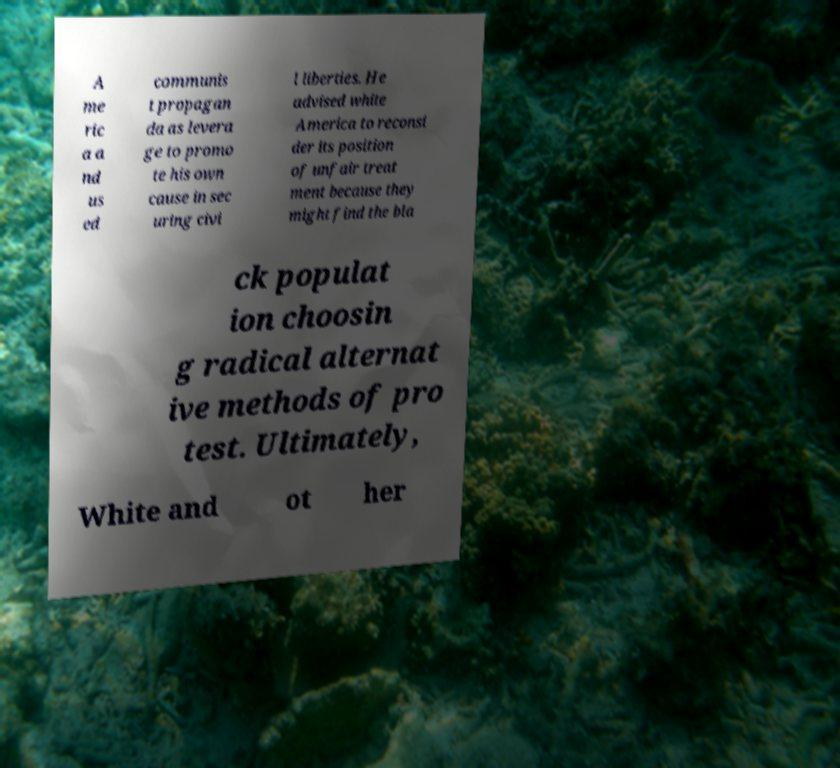Could you assist in decoding the text presented in this image and type it out clearly? A me ric a a nd us ed communis t propagan da as levera ge to promo te his own cause in sec uring civi l liberties. He advised white America to reconsi der its position of unfair treat ment because they might find the bla ck populat ion choosin g radical alternat ive methods of pro test. Ultimately, White and ot her 